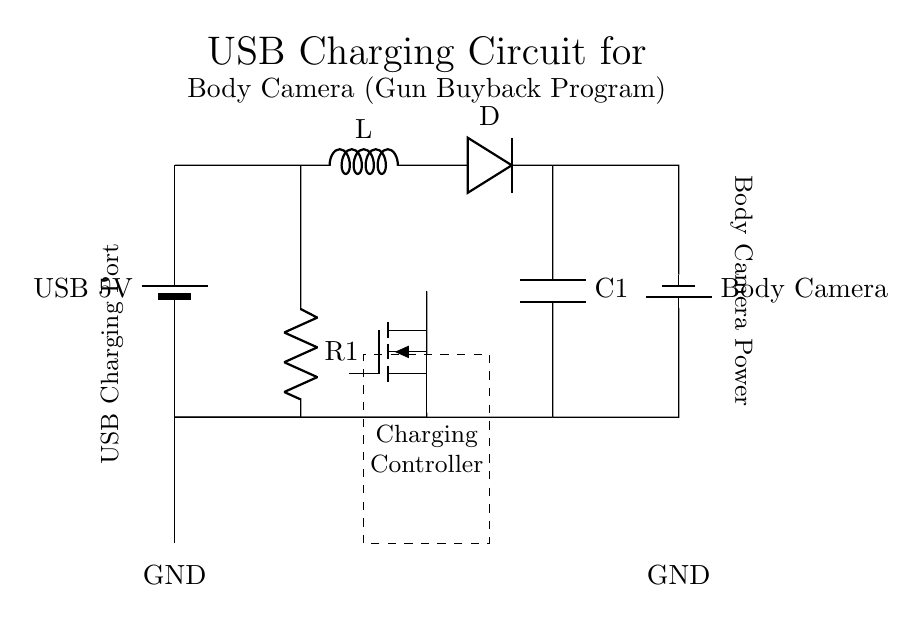What is the input voltage for this circuit? The input voltage is represented by the USB 5V battery symbol at the top left of the circuit diagram. This indicates the circuit is powered by a USB connection providing 5 volts.
Answer: 5 volts What component provides voltage regulation? The component providing voltage regulation is labeled as a 'cute inductor,' which typically functions to stabilize or adjust the voltage levels in circuits. This can be identified by its specific placement and label in the schematic, located between the USB input and the output to the body camera.
Answer: Inductor How many batteries are shown in the circuit? The circuit diagram indicates there are two battery symbols: one for the USB input (5V) and one representing the body camera. A careful examination of the components shows two distinct battery representations.
Answer: Two batteries What is the purpose of the charging controller? The charging controller, indicated by the dashed rectangle, governs the charging process for the body camera's battery, ensuring it receives the proper voltage and current without overcharging. This is essential for managing battery health during the USB charging process.
Answer: Manage charging Which component is connected directly to the body camera? The body camera is connected directly to the battery labeled 'Body Camera' on the right side of the circuit diagram, as indicated by the direct lines showing the connection from the voltage regulator output to this battery symbol.
Answer: Body camera battery 